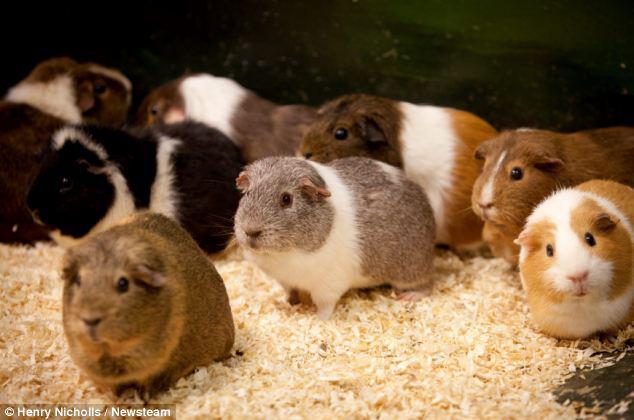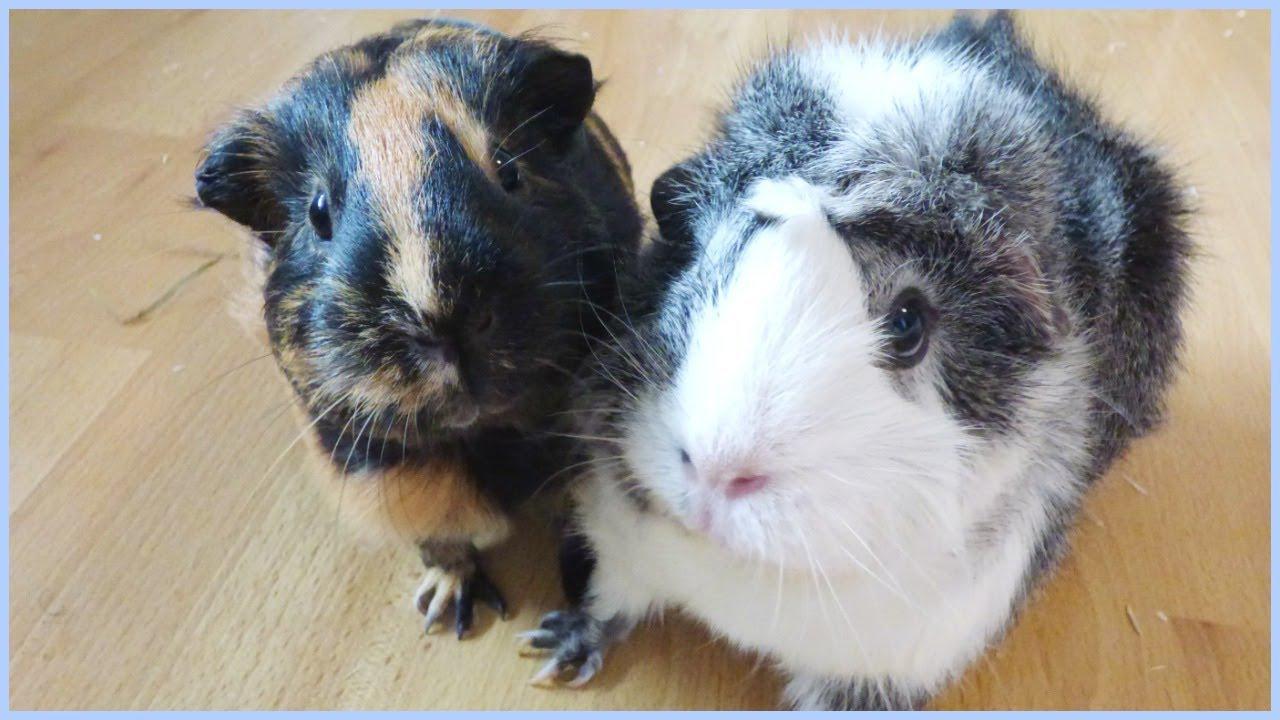The first image is the image on the left, the second image is the image on the right. Evaluate the accuracy of this statement regarding the images: "One image contains only two guinea pigs.". Is it true? Answer yes or no. Yes. The first image is the image on the left, the second image is the image on the right. For the images shown, is this caption "An image shows exactly two hamsters side by side." true? Answer yes or no. Yes. 